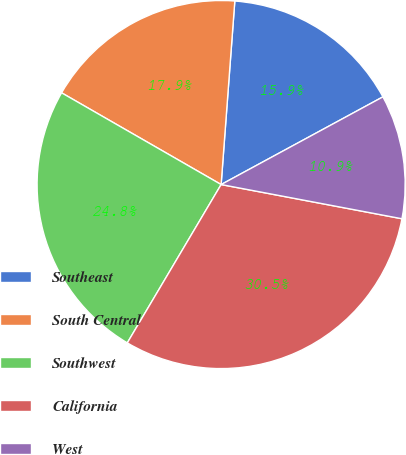Convert chart to OTSL. <chart><loc_0><loc_0><loc_500><loc_500><pie_chart><fcel>Southeast<fcel>South Central<fcel>Southwest<fcel>California<fcel>West<nl><fcel>15.91%<fcel>17.88%<fcel>24.79%<fcel>30.54%<fcel>10.88%<nl></chart> 